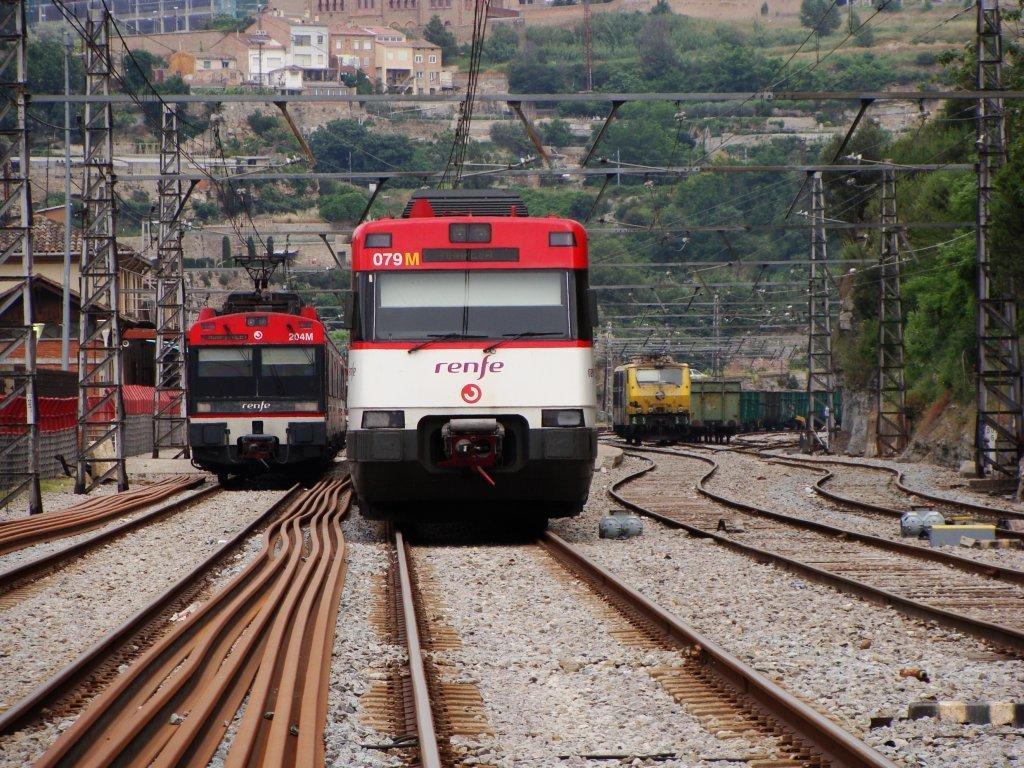How would you summarize this image in a sentence or two? At the bottom of the image there are train tracks with trains. And in the image there are many poles with electrical wires. In the background there are trees and buildings. 